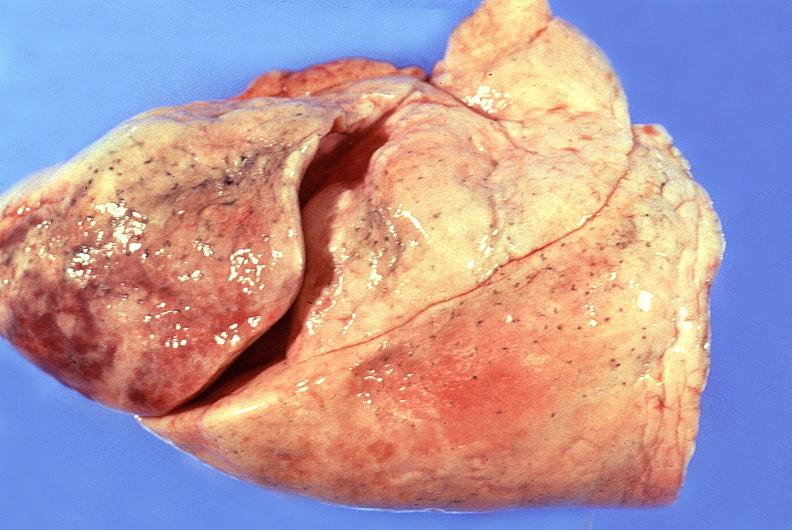does this image show normal lung?
Answer the question using a single word or phrase. Yes 